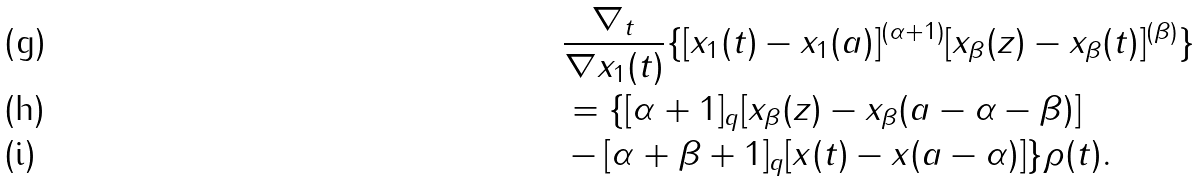Convert formula to latex. <formula><loc_0><loc_0><loc_500><loc_500>& \frac { \nabla _ { t } } { \nabla x _ { 1 } ( t ) } \{ [ x _ { 1 } ( t ) - x _ { 1 } ( a ) ] ^ { ( \alpha + 1 ) } [ x _ { \beta } ( z ) - x _ { \beta } ( t ) ] ^ { ( \beta ) } \} \\ & = \{ [ \alpha + 1 ] _ { q } [ x _ { \beta } ( z ) - x _ { \beta } ( a - \alpha - \beta ) ] \\ & - [ \alpha + \beta + 1 ] _ { q } [ x ( t ) - x ( a - \alpha ) ] \} \rho ( t ) .</formula> 